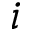<formula> <loc_0><loc_0><loc_500><loc_500>i</formula> 